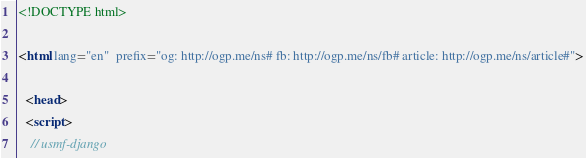<code> <loc_0><loc_0><loc_500><loc_500><_HTML_>

<!DOCTYPE html>

<html lang="en"  prefix="og: http://ogp.me/ns# fb: http://ogp.me/ns/fb# article: http://ogp.me/ns/article#">

  <head>
  <script>
    // usmf-django</code> 